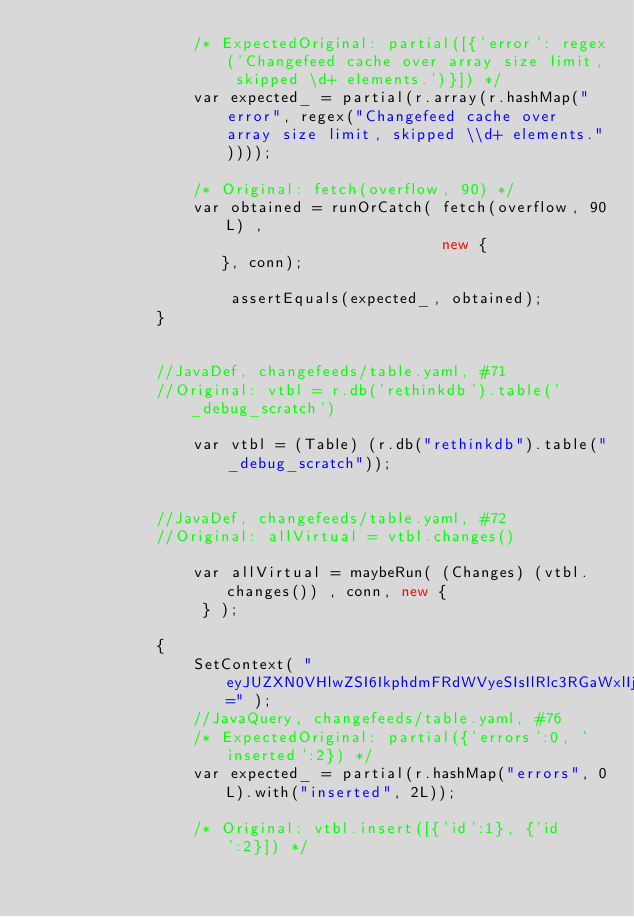<code> <loc_0><loc_0><loc_500><loc_500><_C#_>                 /* ExpectedOriginal: partial([{'error': regex('Changefeed cache over array size limit, skipped \d+ elements.')}]) */
                 var expected_ = partial(r.array(r.hashMap("error", regex("Changefeed cache over array size limit, skipped \\d+ elements."))));
                 
                 /* Original: fetch(overflow, 90) */
                 var obtained = runOrCatch( fetch(overflow, 90L) ,
                                            new {
                    }, conn);
                 
                     assertEquals(expected_, obtained);                 
             }
             
             
             //JavaDef, changefeeds/table.yaml, #71
             //Original: vtbl = r.db('rethinkdb').table('_debug_scratch')
             
                 var vtbl = (Table) (r.db("rethinkdb").table("_debug_scratch"));
             
             
             //JavaDef, changefeeds/table.yaml, #72
             //Original: allVirtual = vtbl.changes()
             
                 var allVirtual = maybeRun( (Changes) (vtbl.changes()) , conn, new {
                  } );
             
             {
                 SetContext( "eyJUZXN0VHlwZSI6IkphdmFRdWVyeSIsIlRlc3RGaWxlIjoiY2hhbmdlZmVlZHMvdGFibGUueWFtbCIsIkxpbmVOdW0iOiI3NiIsIk9yaWdpbmFsIjoidnRibC5pbnNlcnQoW3snaWQnOjF9LCB7J2lkJzoyfV0pIiwiVmFyTmFtZSI6bnVsbCwiVmFyVHlwZSI6bnVsbCwiUnVuSWZRdWVyeSI6ZmFsc2UsIlZhbHVlIjpudWxsLCJKYXZhIjoidnRibC5pbnNlcnQoci5hcnJheShyLmhhc2hNYXAoXCJpZFwiLCAxTCksIHIuaGFzaE1hcChcImlkXCIsIDJMKSkpIiwiRXhwZWN0ZWRPcmlnaW5hbCI6InBhcnRpYWwoeydlcnJvcnMnOjAsICdpbnNlcnRlZCc6Mn0pIiwiRXhwZWN0ZWRUeXBlIjoiUGFydGlhbCIsIkV4cGVjdGVkSmF2YSI6InBhcnRpYWwoci5oYXNoTWFwKFwiZXJyb3JzXCIsIDBMKS53aXRoKFwiaW5zZXJ0ZWRcIiwgMkwpKSIsIk9idGFpbmVkIjpudWxsLCJSdW5PcHRzIjpbXSwiUmVuZGVyU29tZXRoaW5nIjpmYWxzZX0=" );
                 //JavaQuery, changefeeds/table.yaml, #76
                 /* ExpectedOriginal: partial({'errors':0, 'inserted':2}) */
                 var expected_ = partial(r.hashMap("errors", 0L).with("inserted", 2L));
                 
                 /* Original: vtbl.insert([{'id':1}, {'id':2}]) */</code> 